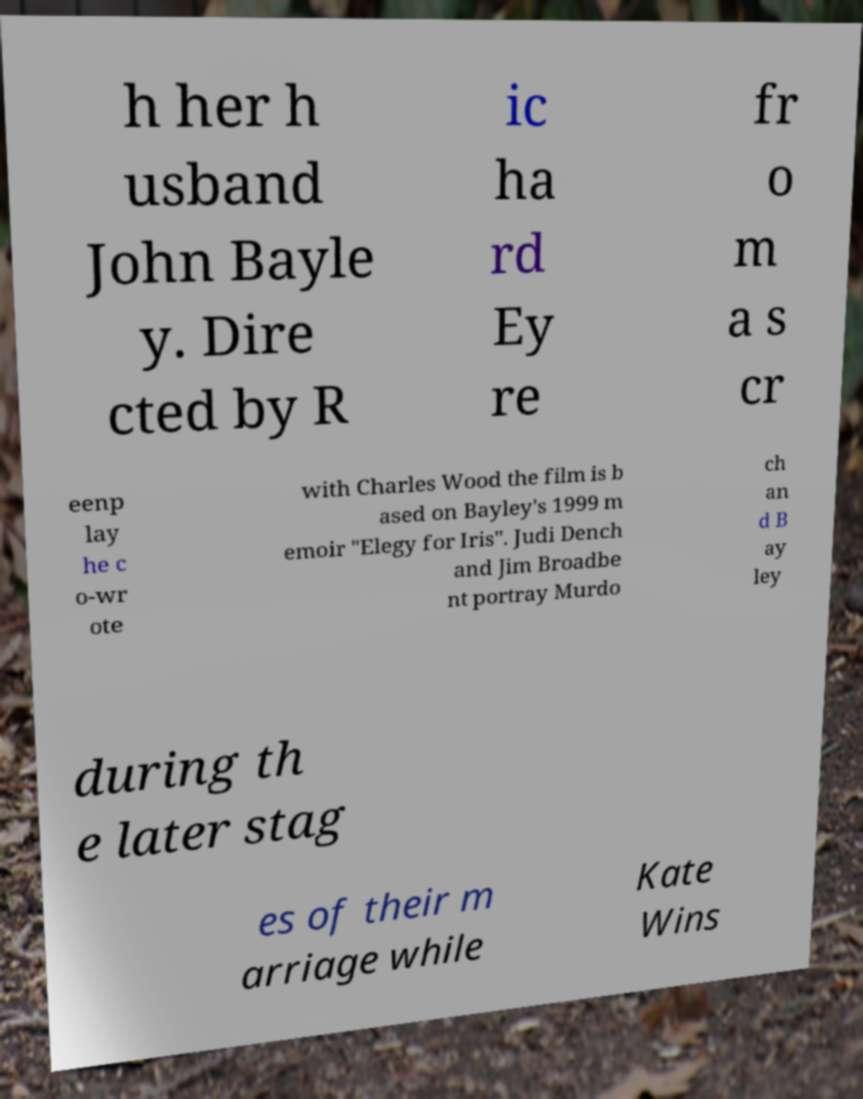Please identify and transcribe the text found in this image. h her h usband John Bayle y. Dire cted by R ic ha rd Ey re fr o m a s cr eenp lay he c o-wr ote with Charles Wood the film is b ased on Bayley's 1999 m emoir "Elegy for Iris". Judi Dench and Jim Broadbe nt portray Murdo ch an d B ay ley during th e later stag es of their m arriage while Kate Wins 